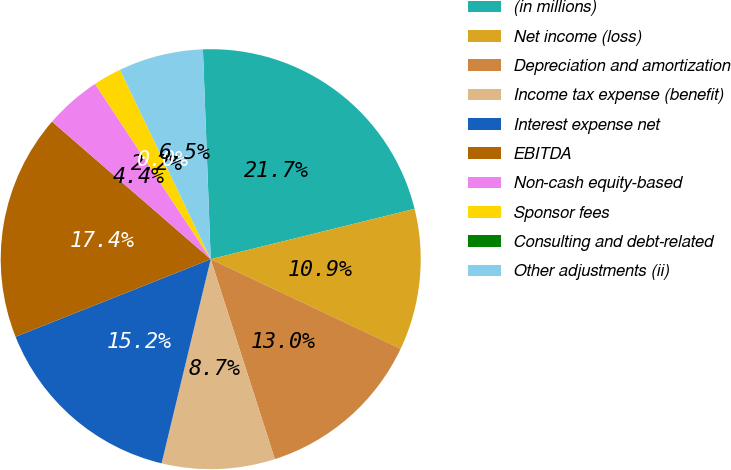Convert chart. <chart><loc_0><loc_0><loc_500><loc_500><pie_chart><fcel>(in millions)<fcel>Net income (loss)<fcel>Depreciation and amortization<fcel>Income tax expense (benefit)<fcel>Interest expense net<fcel>EBITDA<fcel>Non-cash equity-based<fcel>Sponsor fees<fcel>Consulting and debt-related<fcel>Other adjustments (ii)<nl><fcel>21.74%<fcel>10.87%<fcel>13.04%<fcel>8.7%<fcel>15.22%<fcel>17.39%<fcel>4.35%<fcel>2.17%<fcel>0.0%<fcel>6.52%<nl></chart> 